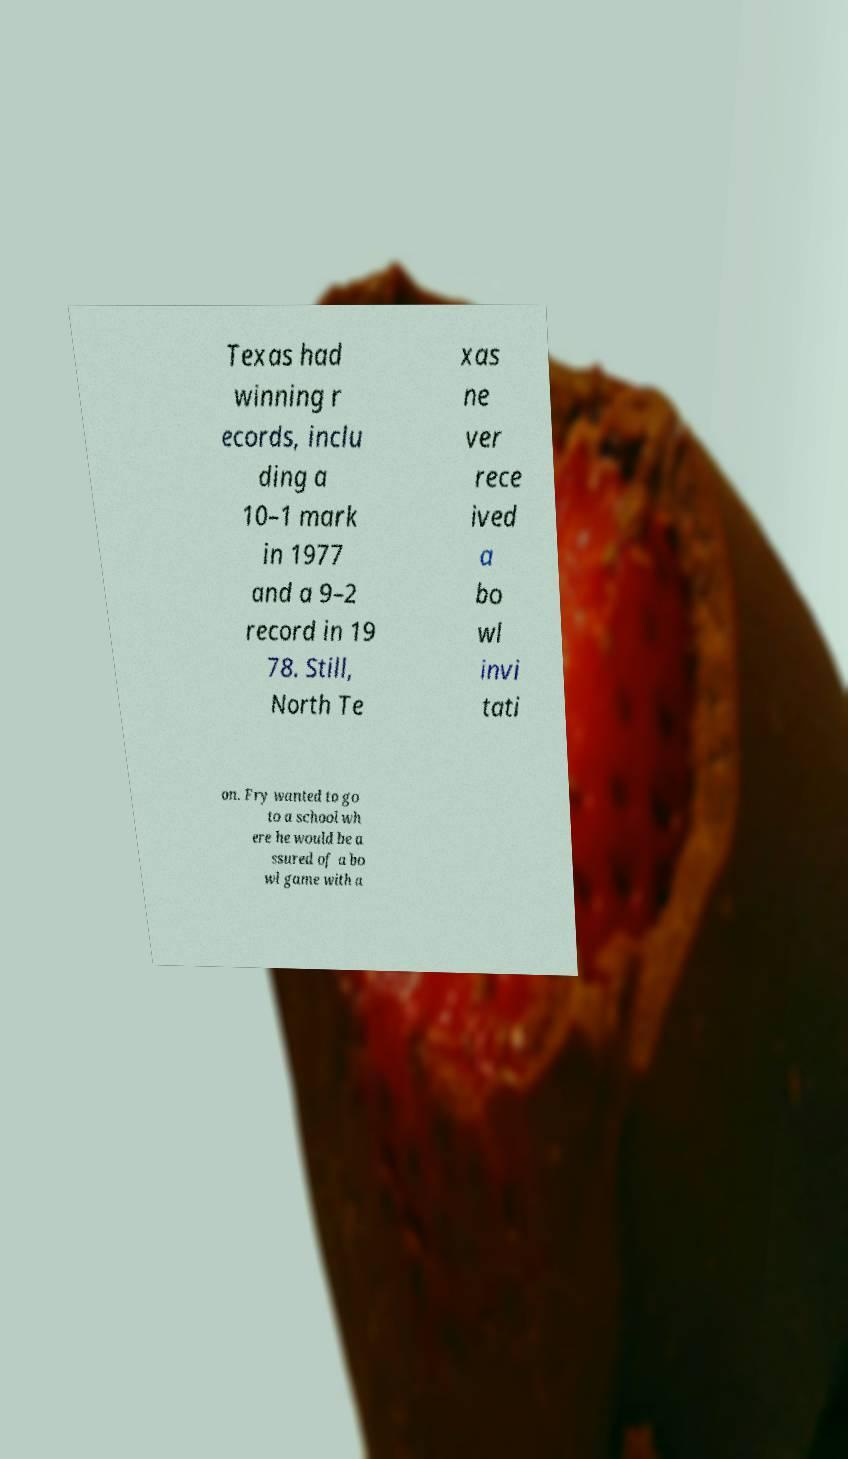Please read and relay the text visible in this image. What does it say? Texas had winning r ecords, inclu ding a 10–1 mark in 1977 and a 9–2 record in 19 78. Still, North Te xas ne ver rece ived a bo wl invi tati on. Fry wanted to go to a school wh ere he would be a ssured of a bo wl game with a 